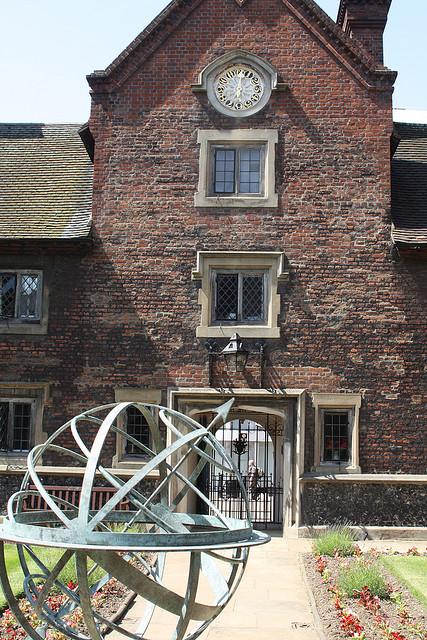What does the sculpture represent?
Concise answer only. Globe. In what direction is the arrow inside the green art piece pointing?
Concise answer only. Right. How old do you think this building is?
Be succinct. 100 years. 